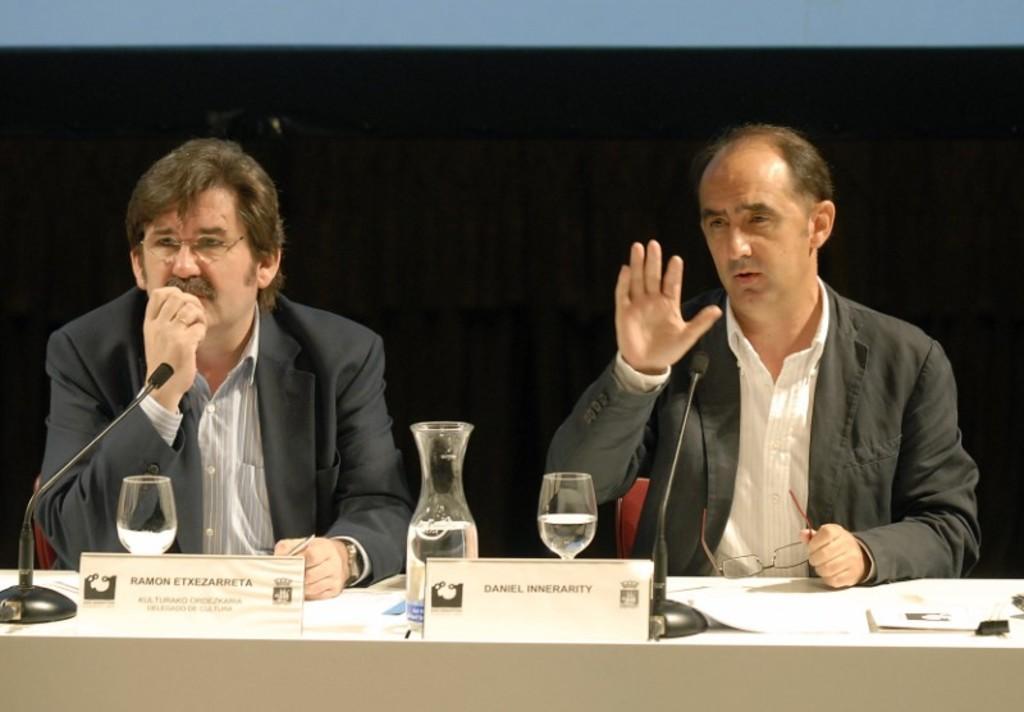Please provide a concise description of this image. There are two men sitting. This is a table. I can see the name boards, water jug, wine glasses, mike's, files and few other things on it. The background looks dark. 